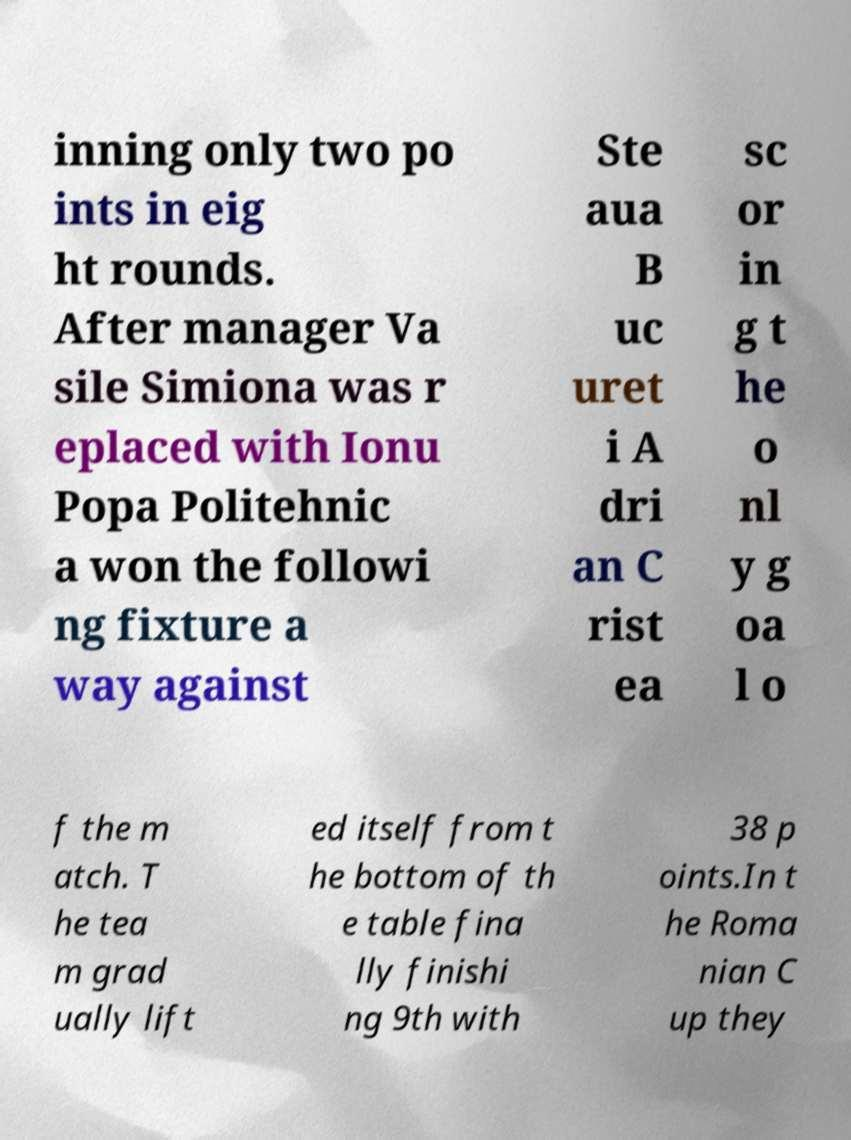Can you accurately transcribe the text from the provided image for me? inning only two po ints in eig ht rounds. After manager Va sile Simiona was r eplaced with Ionu Popa Politehnic a won the followi ng fixture a way against Ste aua B uc uret i A dri an C rist ea sc or in g t he o nl y g oa l o f the m atch. T he tea m grad ually lift ed itself from t he bottom of th e table fina lly finishi ng 9th with 38 p oints.In t he Roma nian C up they 